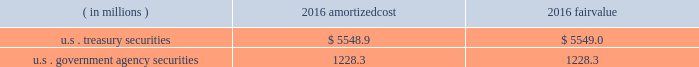Each clearing firm is required to deposit and maintain balances in the form of cash , u.s .
Government securities , certain foreign government securities , bank letters of credit or other approved investments to satisfy performance bond and guaranty fund requirements .
All non-cash deposits are marked-to-market and haircut on a daily basis .
Securities deposited by the clearing firms are not reflected in the consolidated financial statements and the clearing house does not earn any interest on these deposits .
These balances may fluctuate significantly over time due to investment choices available to clearing firms and changes in the amount of contributions required .
In addition , the rules and regulations of cbot require that collateral be provided for delivery of physical commodities , maintenance of capital requirements and deposits on pending arbitration matters .
To satisfy these requirements , clearing firms that have accounts that trade certain cbot products have deposited cash , u.s .
Treasury securities or letters of credit .
The clearing house marks-to-market open positions at least once a day ( twice a day for futures and options contracts ) , and require payment from clearing firms whose positions have lost value and make payments to clearing firms whose positions have gained value .
The clearing house has the capability to mark-to-market more frequently as market conditions warrant .
Under the extremely unlikely scenario of simultaneous default by every clearing firm who has open positions with unrealized losses , the maximum exposure related to positions other than credit default and interest rate swap contracts would be one half day of changes in fair value of all open positions , before considering the clearing houses 2019 ability to access defaulting clearing firms 2019 collateral deposits .
For cleared credit default swap and interest rate swap contracts , the maximum exposure related to cme 2019s guarantee would be one full day of changes in fair value of all open positions , before considering cme 2019s ability to access defaulting clearing firms 2019 collateral .
During 2017 , the clearing house transferred an average of approximately $ 2.4 billion a day through the clearing system for settlement from clearing firms whose positions had lost value to clearing firms whose positions had gained value .
The clearing house reduces the guarantee exposure through initial and maintenance performance bond requirements and mandatory guaranty fund contributions .
The company believes that the guarantee liability is immaterial and therefore has not recorded any liability at december 31 , 2017 .
At december 31 , 2016 , performance bond and guaranty fund contribution assets on the consolidated balance sheets included cash as well as u.s .
Treasury and u.s .
Government agency securities with maturity dates of 90 days or less .
The u.s .
Treasury and u.s .
Government agency securities were purchased by cme , at its discretion , using cash collateral .
The benefits , including interest earned , and risks of ownership accrue to cme .
Interest earned is included in investment income on the consolidated statements of income .
There were no u.s .
Treasury and u.s .
Government agency securities held at december 31 , 2017 .
The amortized cost and fair value of these securities at december 31 , 2016 were as follows : ( in millions ) amortized .
Cme has been designated as a systemically important financial market utility by the financial stability oversight council and maintains a cash account at the federal reserve bank of chicago .
At december 31 , 2017 and december 31 , 2016 , cme maintained $ 34.2 billion and $ 6.2 billion , respectively , within the cash account at the federal reserve bank of chicago .
Clearing firms , at their option , may instruct cme to deposit the cash held by cme into one of the ief programs .
The total principal in the ief programs was $ 1.1 billion at december 31 , 2017 and $ 6.8 billion at december 31 .
What was the average principal in the ief programs at december 31 , 2017 and 2016 , in billions? 
Computations: ((1.1 + 6.8) / 2)
Answer: 3.95. 